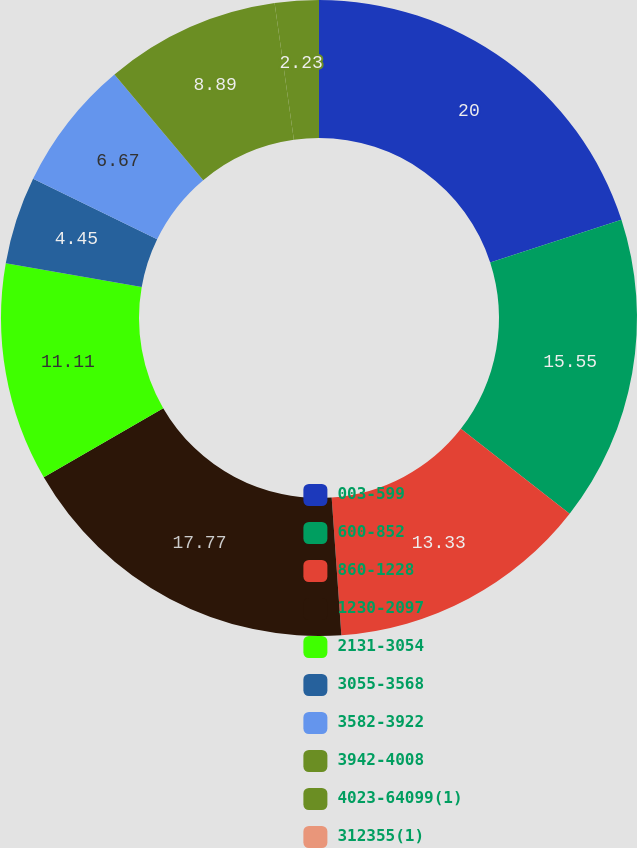<chart> <loc_0><loc_0><loc_500><loc_500><pie_chart><fcel>003-599<fcel>600-852<fcel>860-1228<fcel>1230-2097<fcel>2131-3054<fcel>3055-3568<fcel>3582-3922<fcel>3942-4008<fcel>4023-64099(1)<fcel>312355(1)<nl><fcel>20.0%<fcel>15.55%<fcel>13.33%<fcel>17.77%<fcel>11.11%<fcel>4.45%<fcel>6.67%<fcel>8.89%<fcel>2.23%<fcel>0.0%<nl></chart> 